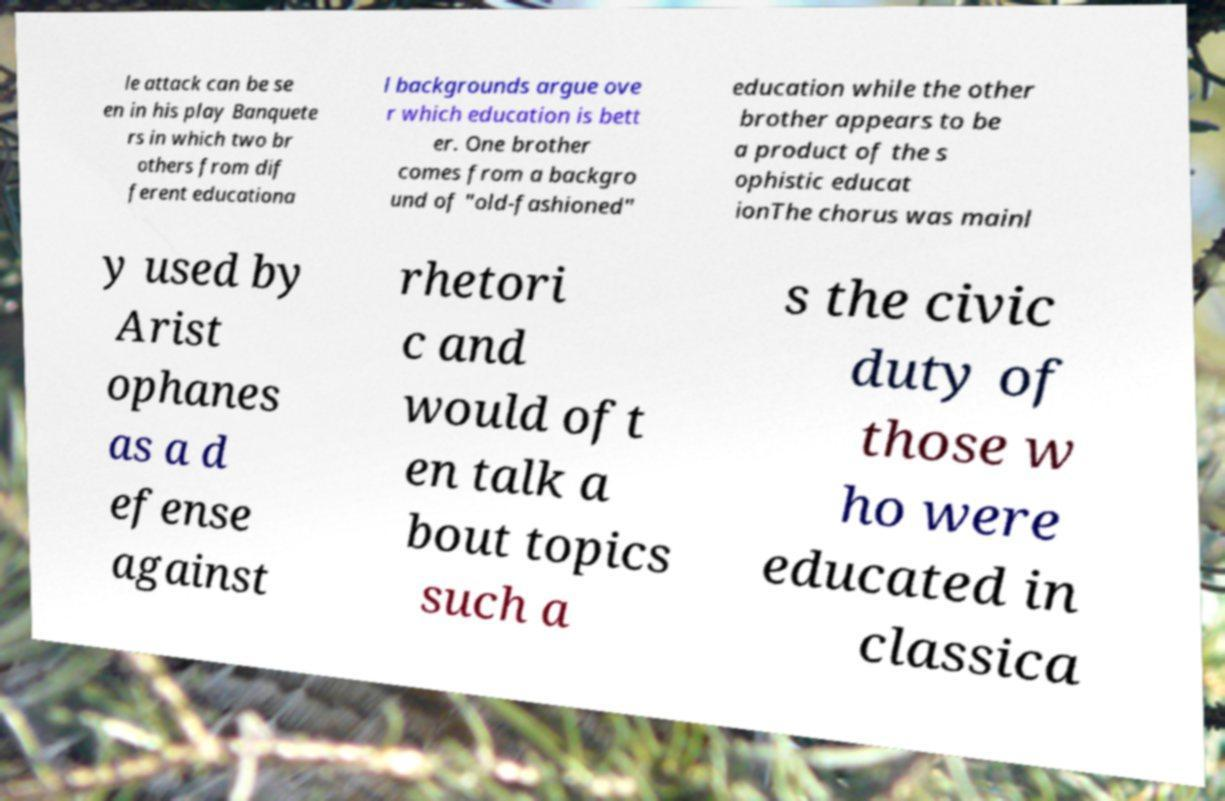There's text embedded in this image that I need extracted. Can you transcribe it verbatim? le attack can be se en in his play Banquete rs in which two br others from dif ferent educationa l backgrounds argue ove r which education is bett er. One brother comes from a backgro und of "old-fashioned" education while the other brother appears to be a product of the s ophistic educat ionThe chorus was mainl y used by Arist ophanes as a d efense against rhetori c and would oft en talk a bout topics such a s the civic duty of those w ho were educated in classica 